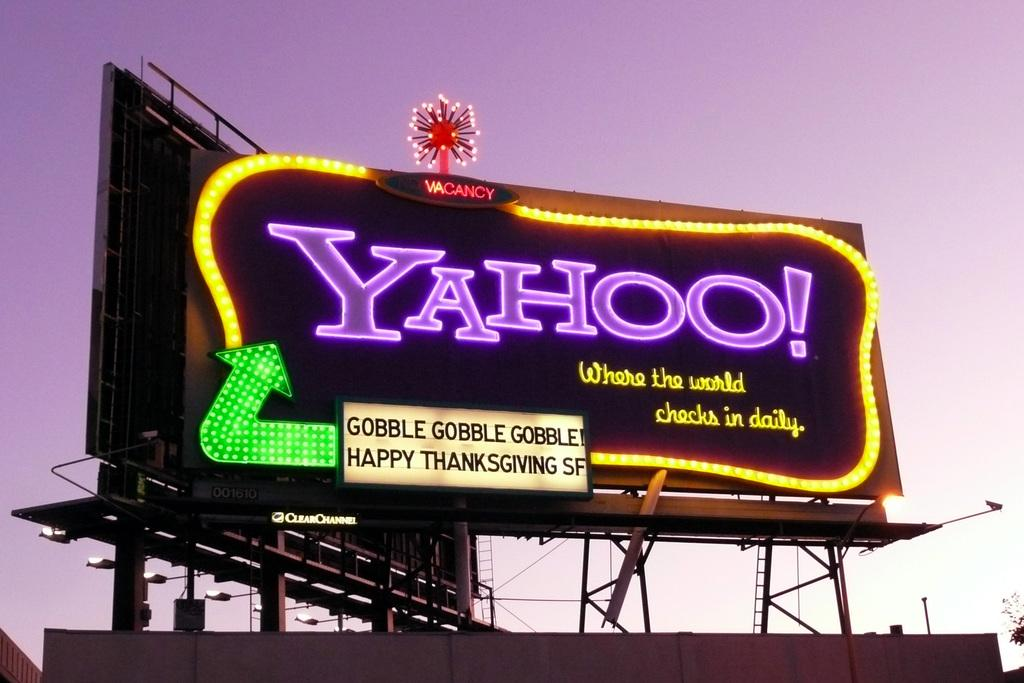<image>
Summarize the visual content of the image. A  neon billboard with purple letters saying Yahoo. 